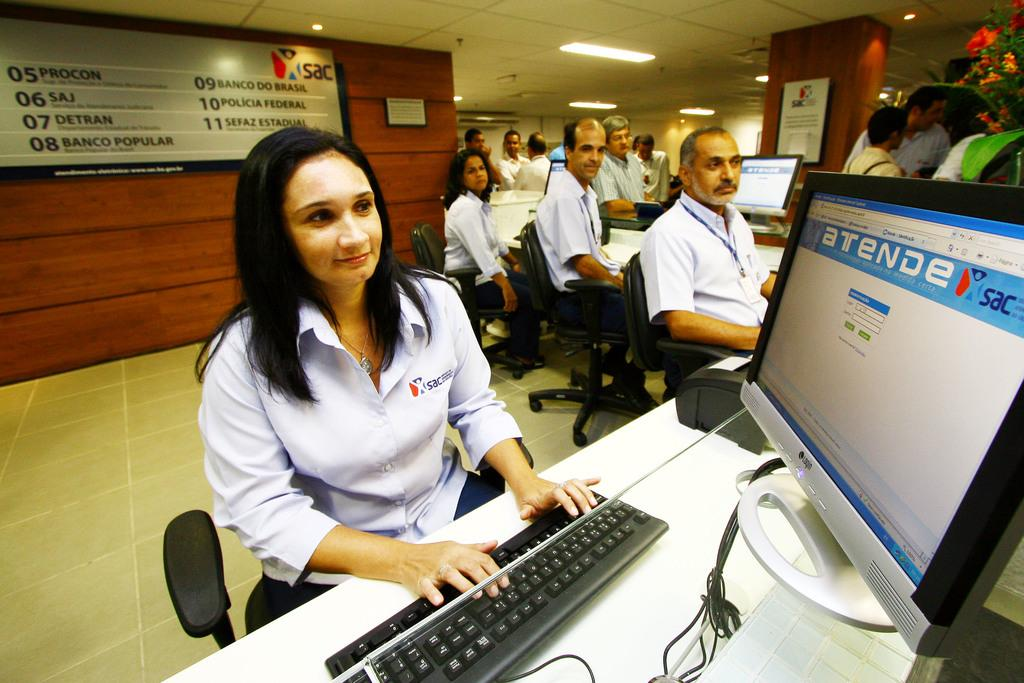<image>
Summarize the visual content of the image. Tellers working in front of a sign for SAC 